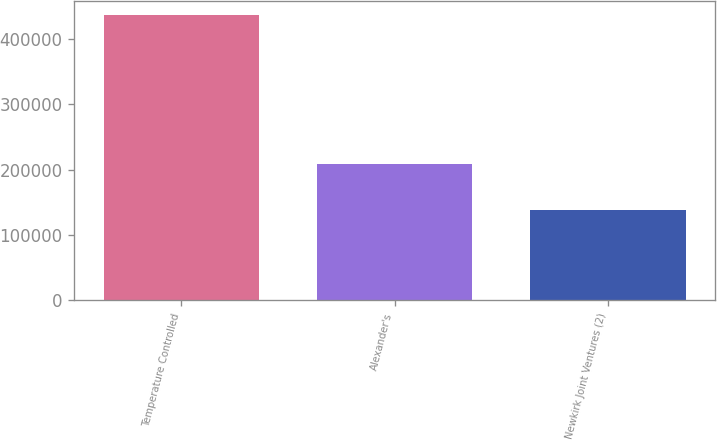Convert chart to OTSL. <chart><loc_0><loc_0><loc_500><loc_500><bar_chart><fcel>Temperature Controlled<fcel>Alexander's<fcel>Newkirk Joint Ventures (2)<nl><fcel>436225<fcel>207872<fcel>138762<nl></chart> 